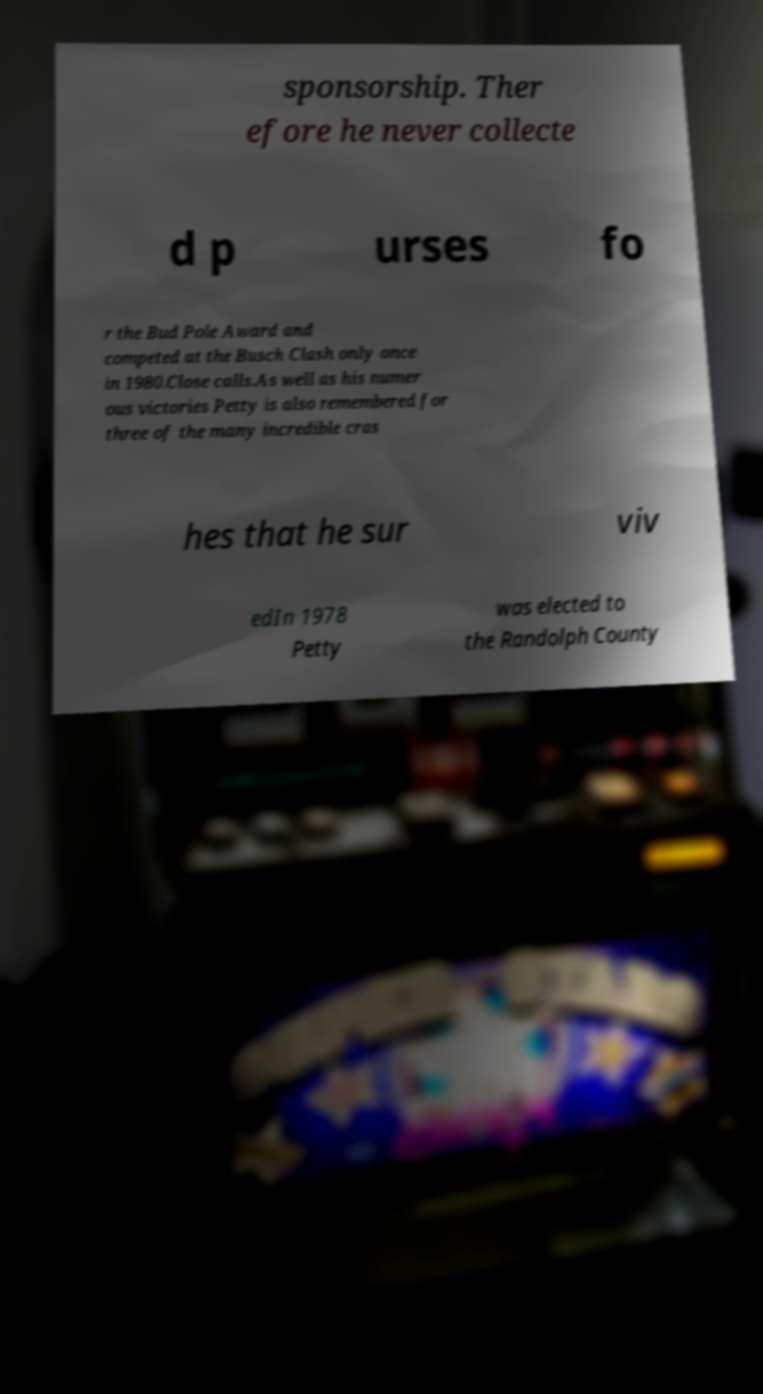Can you accurately transcribe the text from the provided image for me? sponsorship. Ther efore he never collecte d p urses fo r the Bud Pole Award and competed at the Busch Clash only once in 1980.Close calls.As well as his numer ous victories Petty is also remembered for three of the many incredible cras hes that he sur viv edIn 1978 Petty was elected to the Randolph County 